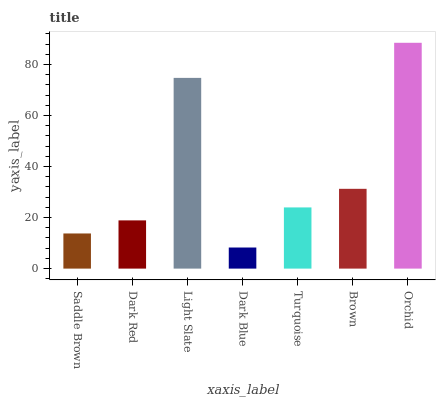Is Dark Blue the minimum?
Answer yes or no. Yes. Is Orchid the maximum?
Answer yes or no. Yes. Is Dark Red the minimum?
Answer yes or no. No. Is Dark Red the maximum?
Answer yes or no. No. Is Dark Red greater than Saddle Brown?
Answer yes or no. Yes. Is Saddle Brown less than Dark Red?
Answer yes or no. Yes. Is Saddle Brown greater than Dark Red?
Answer yes or no. No. Is Dark Red less than Saddle Brown?
Answer yes or no. No. Is Turquoise the high median?
Answer yes or no. Yes. Is Turquoise the low median?
Answer yes or no. Yes. Is Dark Blue the high median?
Answer yes or no. No. Is Saddle Brown the low median?
Answer yes or no. No. 